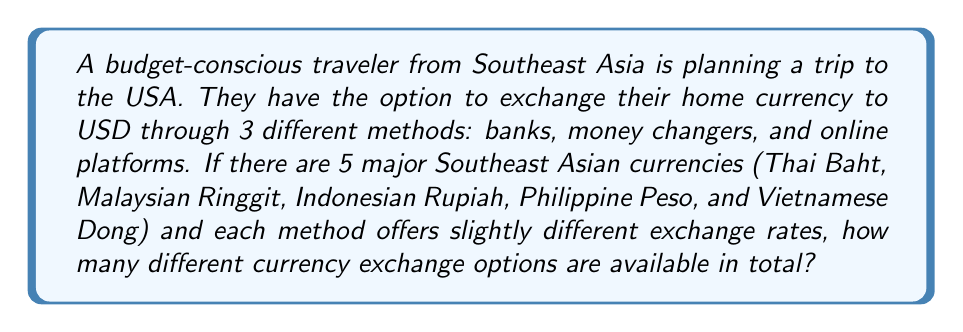What is the answer to this math problem? Let's approach this step-by-step:

1) We need to identify the key components of the problem:
   - There are 5 Southeast Asian currencies
   - There are 3 methods of exchange

2) For each currency, the traveler has 3 options to choose from (bank, money changer, or online platform).

3) This scenario can be modeled as a multiplication principle problem. The multiplication principle states that if we have $m$ ways of doing something and $n$ ways of doing another thing, then there are $m \times n$ ways of doing both things.

4) In this case, we have:
   - 5 choices for the currency
   - 3 choices for the exchange method

5) Therefore, the total number of different currency exchange options is:

   $$ \text{Total options} = \text{Number of currencies} \times \text{Number of exchange methods} $$
   $$ \text{Total options} = 5 \times 3 = 15 $$

Thus, there are 15 different currency exchange options available for the traveler.
Answer: 15 options 